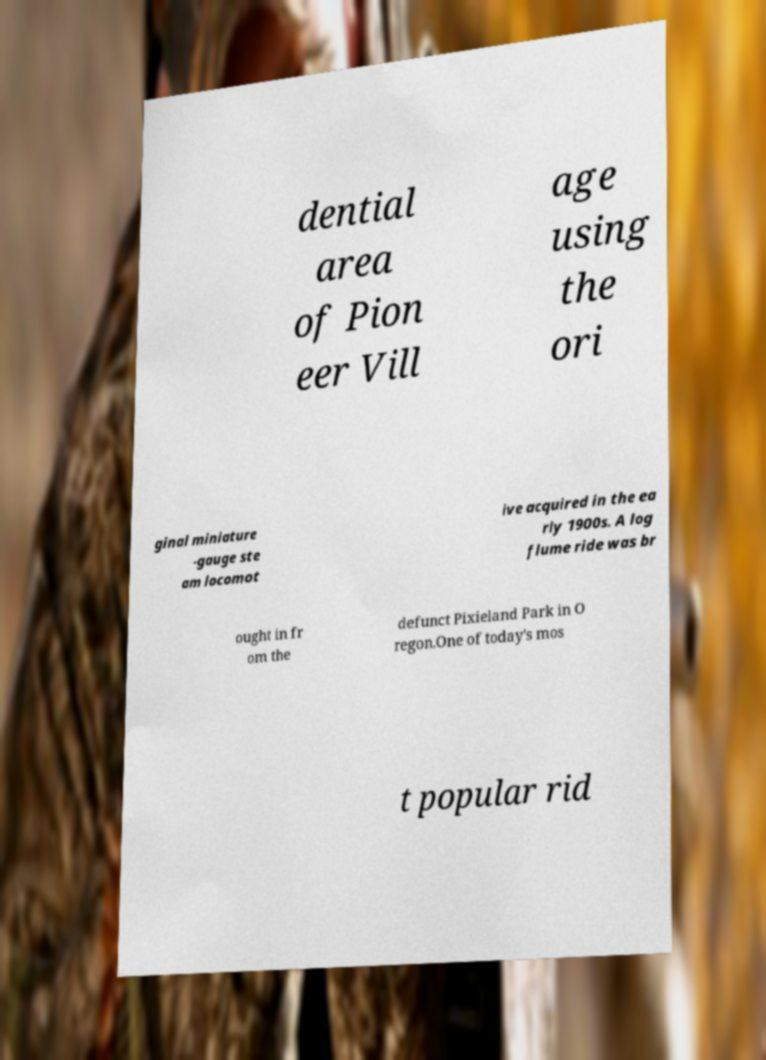Can you read and provide the text displayed in the image?This photo seems to have some interesting text. Can you extract and type it out for me? dential area of Pion eer Vill age using the ori ginal miniature -gauge ste am locomot ive acquired in the ea rly 1900s. A log flume ride was br ought in fr om the defunct Pixieland Park in O regon.One of today's mos t popular rid 